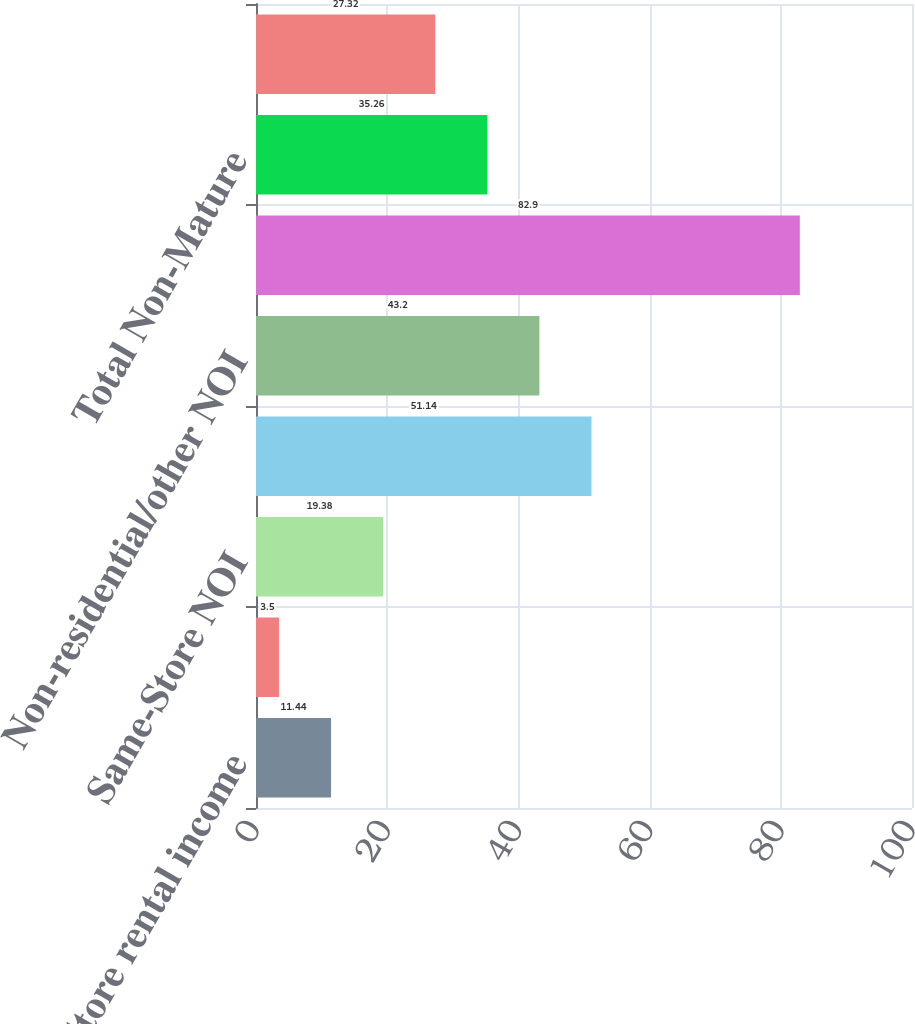Convert chart. <chart><loc_0><loc_0><loc_500><loc_500><bar_chart><fcel>Same-Store rental income<fcel>Same-Store operating expense<fcel>Same-Store NOI<fcel>NOI (d)<fcel>Non-residential/other NOI<fcel>Sold and held for disposition<fcel>Total Non-Mature<fcel>Total property NOI<nl><fcel>11.44<fcel>3.5<fcel>19.38<fcel>51.14<fcel>43.2<fcel>82.9<fcel>35.26<fcel>27.32<nl></chart> 